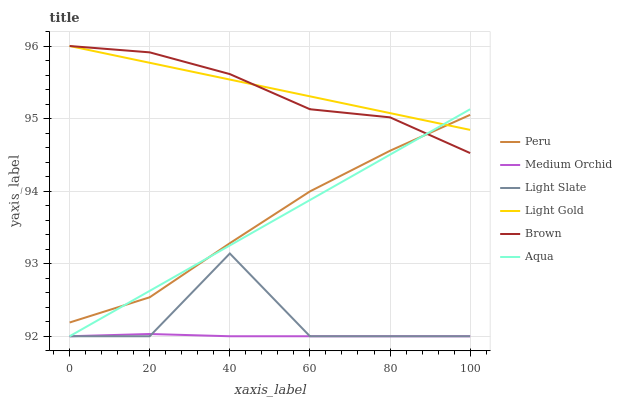Does Light Slate have the minimum area under the curve?
Answer yes or no. No. Does Light Slate have the maximum area under the curve?
Answer yes or no. No. Is Medium Orchid the smoothest?
Answer yes or no. No. Is Medium Orchid the roughest?
Answer yes or no. No. Does Peru have the lowest value?
Answer yes or no. No. Does Light Slate have the highest value?
Answer yes or no. No. Is Light Slate less than Brown?
Answer yes or no. Yes. Is Peru greater than Light Slate?
Answer yes or no. Yes. Does Light Slate intersect Brown?
Answer yes or no. No. 